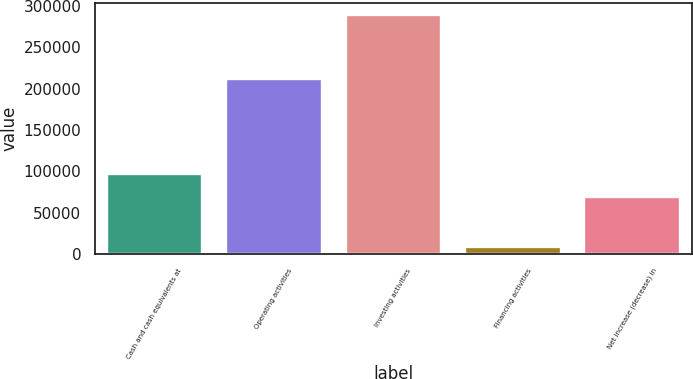Convert chart. <chart><loc_0><loc_0><loc_500><loc_500><bar_chart><fcel>Cash and cash equivalents at<fcel>Operating activities<fcel>Investing activities<fcel>Financing activities<fcel>Net increase (decrease) in<nl><fcel>96876.1<fcel>212280<fcel>289444<fcel>8393<fcel>68771<nl></chart> 